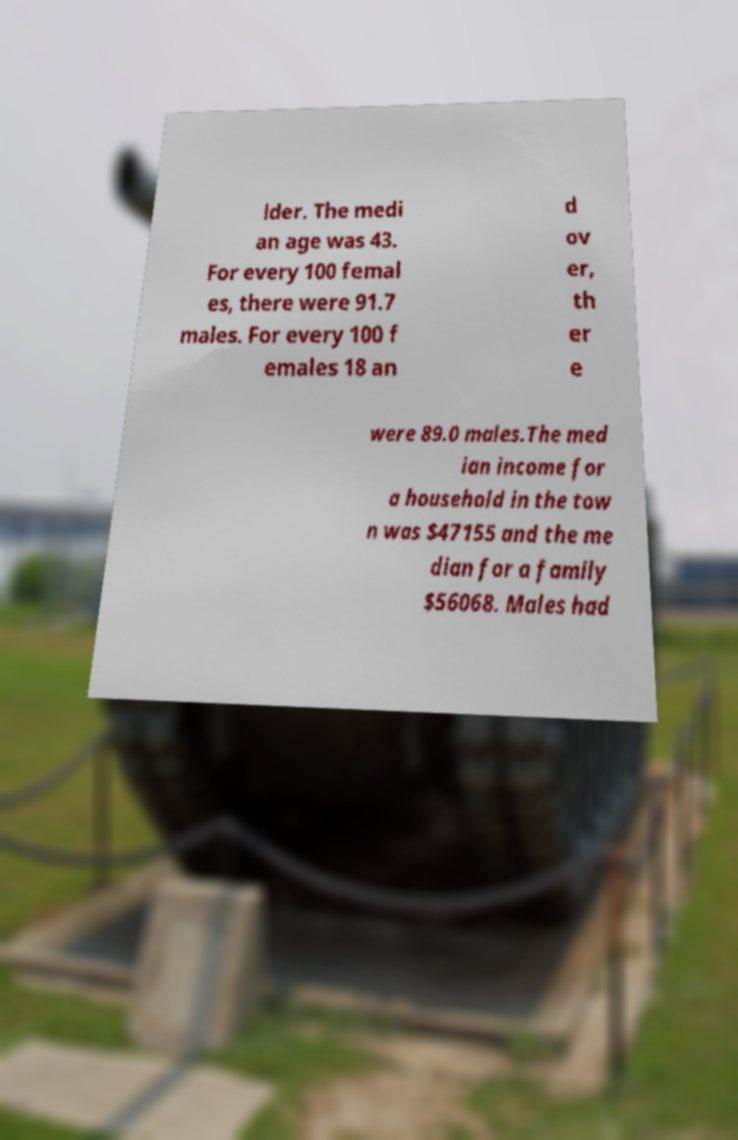Please read and relay the text visible in this image. What does it say? lder. The medi an age was 43. For every 100 femal es, there were 91.7 males. For every 100 f emales 18 an d ov er, th er e were 89.0 males.The med ian income for a household in the tow n was $47155 and the me dian for a family $56068. Males had 